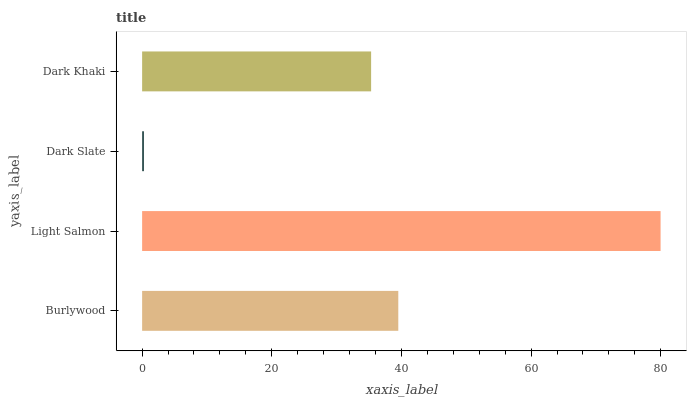Is Dark Slate the minimum?
Answer yes or no. Yes. Is Light Salmon the maximum?
Answer yes or no. Yes. Is Light Salmon the minimum?
Answer yes or no. No. Is Dark Slate the maximum?
Answer yes or no. No. Is Light Salmon greater than Dark Slate?
Answer yes or no. Yes. Is Dark Slate less than Light Salmon?
Answer yes or no. Yes. Is Dark Slate greater than Light Salmon?
Answer yes or no. No. Is Light Salmon less than Dark Slate?
Answer yes or no. No. Is Burlywood the high median?
Answer yes or no. Yes. Is Dark Khaki the low median?
Answer yes or no. Yes. Is Light Salmon the high median?
Answer yes or no. No. Is Dark Slate the low median?
Answer yes or no. No. 